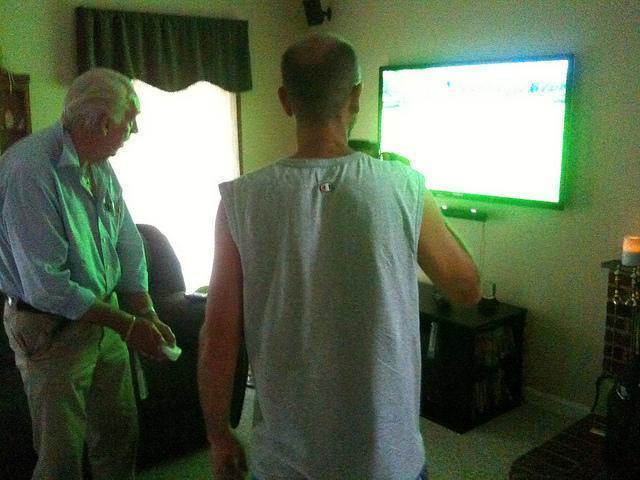Which sport is the man on the left most likely playing on the nintendo wii appliance?
Pick the right solution, then justify: 'Answer: answer
Rationale: rationale.'
Options: Tennis, baseball, golf, boxing. Answer: golf.
Rationale: The man is holding his control down as if putting. 